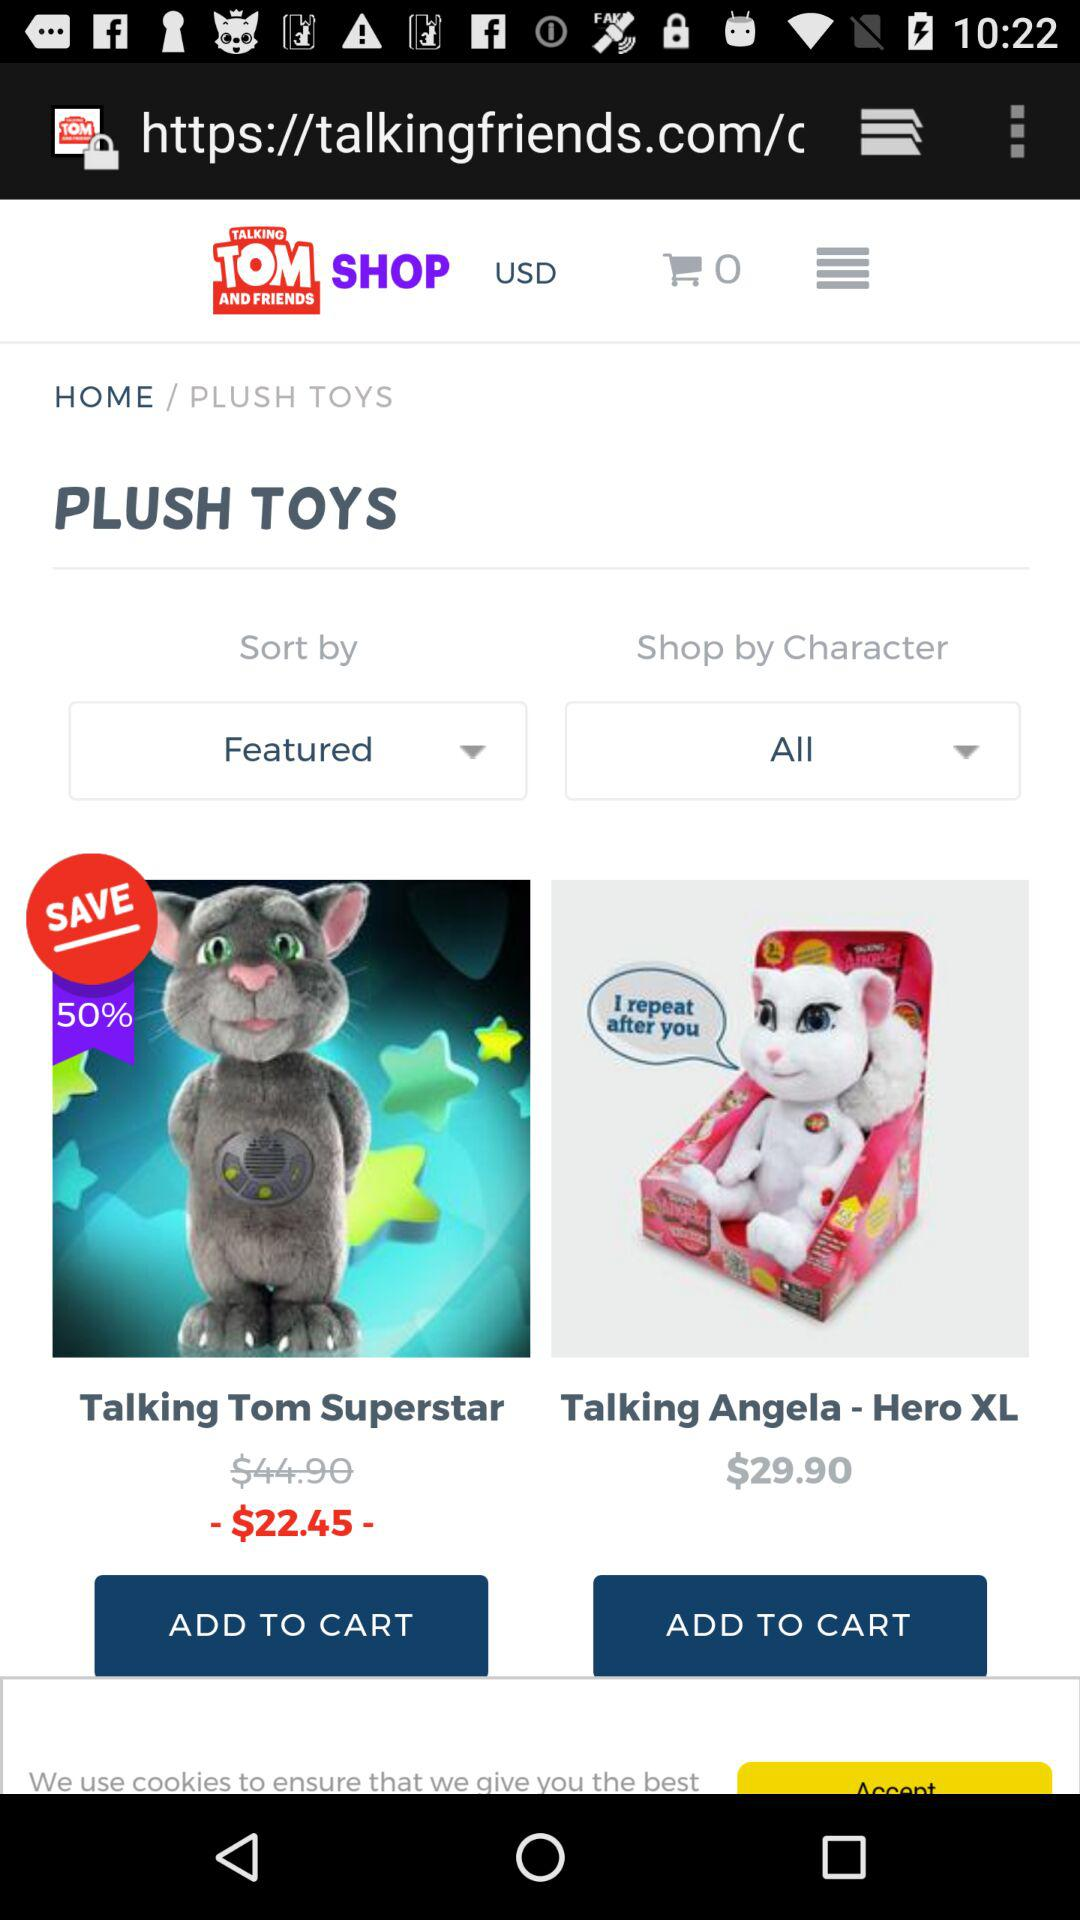What is the discount on "Talking Tom Superstar"? The discount is 50%. 